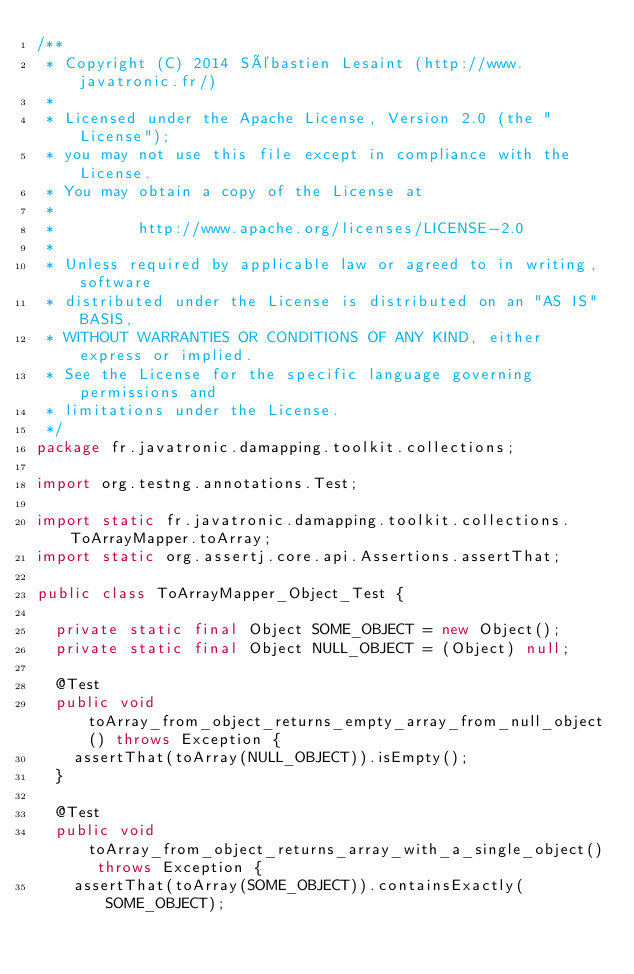Convert code to text. <code><loc_0><loc_0><loc_500><loc_500><_Java_>/**
 * Copyright (C) 2014 Sébastien Lesaint (http://www.javatronic.fr/)
 *
 * Licensed under the Apache License, Version 2.0 (the "License");
 * you may not use this file except in compliance with the License.
 * You may obtain a copy of the License at
 *
 *         http://www.apache.org/licenses/LICENSE-2.0
 *
 * Unless required by applicable law or agreed to in writing, software
 * distributed under the License is distributed on an "AS IS" BASIS,
 * WITHOUT WARRANTIES OR CONDITIONS OF ANY KIND, either express or implied.
 * See the License for the specific language governing permissions and
 * limitations under the License.
 */
package fr.javatronic.damapping.toolkit.collections;

import org.testng.annotations.Test;

import static fr.javatronic.damapping.toolkit.collections.ToArrayMapper.toArray;
import static org.assertj.core.api.Assertions.assertThat;

public class ToArrayMapper_Object_Test {

  private static final Object SOME_OBJECT = new Object();
  private static final Object NULL_OBJECT = (Object) null;

  @Test
  public void toArray_from_object_returns_empty_array_from_null_object() throws Exception {
    assertThat(toArray(NULL_OBJECT)).isEmpty();
  }

  @Test
  public void toArray_from_object_returns_array_with_a_single_object() throws Exception {
    assertThat(toArray(SOME_OBJECT)).containsExactly(SOME_OBJECT);</code> 